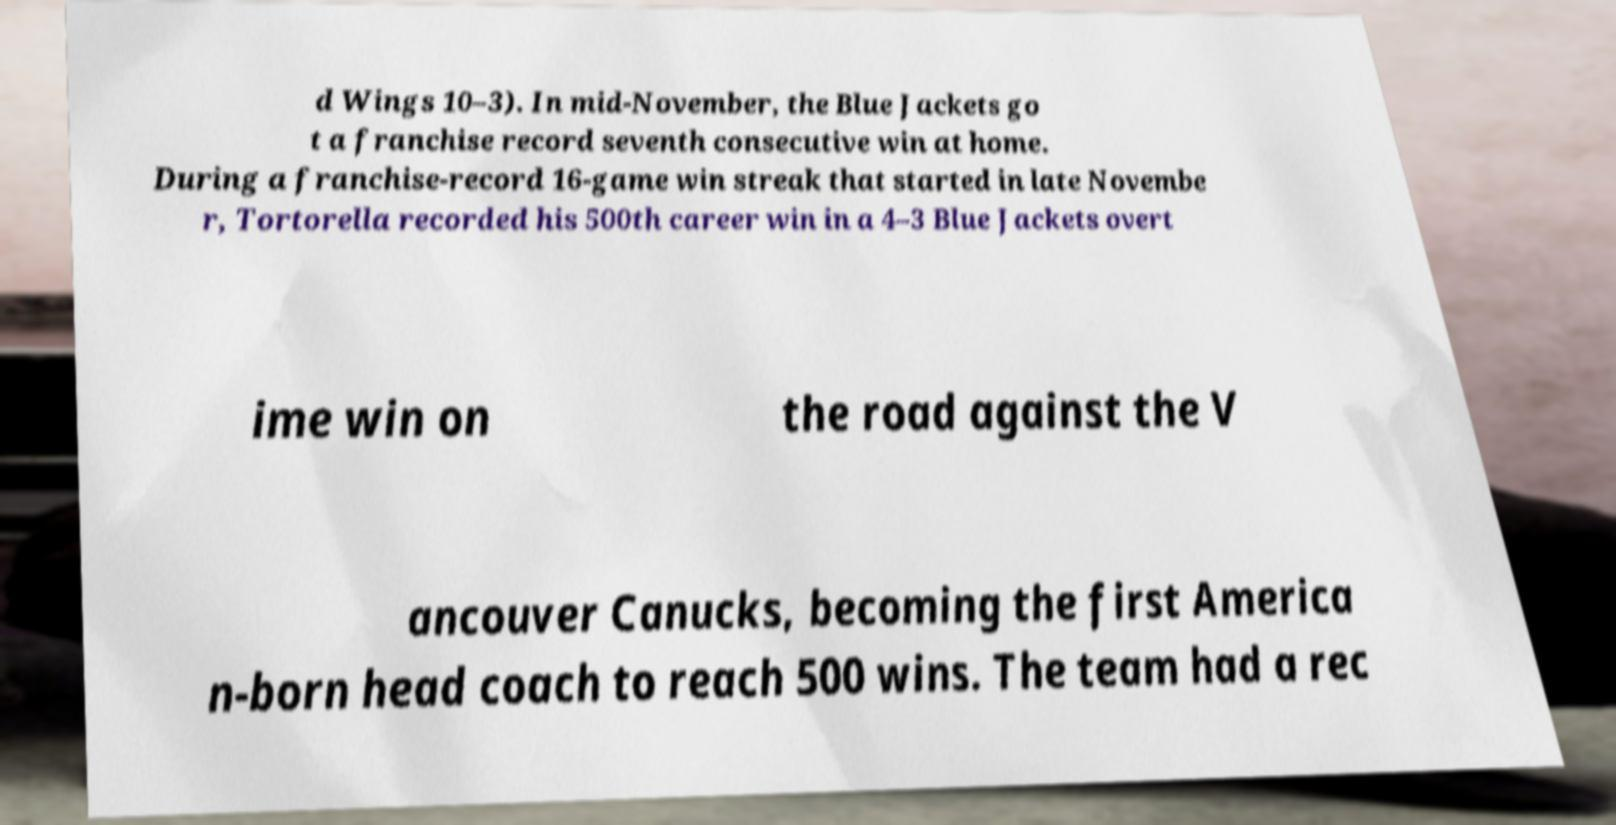Could you assist in decoding the text presented in this image and type it out clearly? d Wings 10–3). In mid-November, the Blue Jackets go t a franchise record seventh consecutive win at home. During a franchise-record 16-game win streak that started in late Novembe r, Tortorella recorded his 500th career win in a 4–3 Blue Jackets overt ime win on the road against the V ancouver Canucks, becoming the first America n-born head coach to reach 500 wins. The team had a rec 